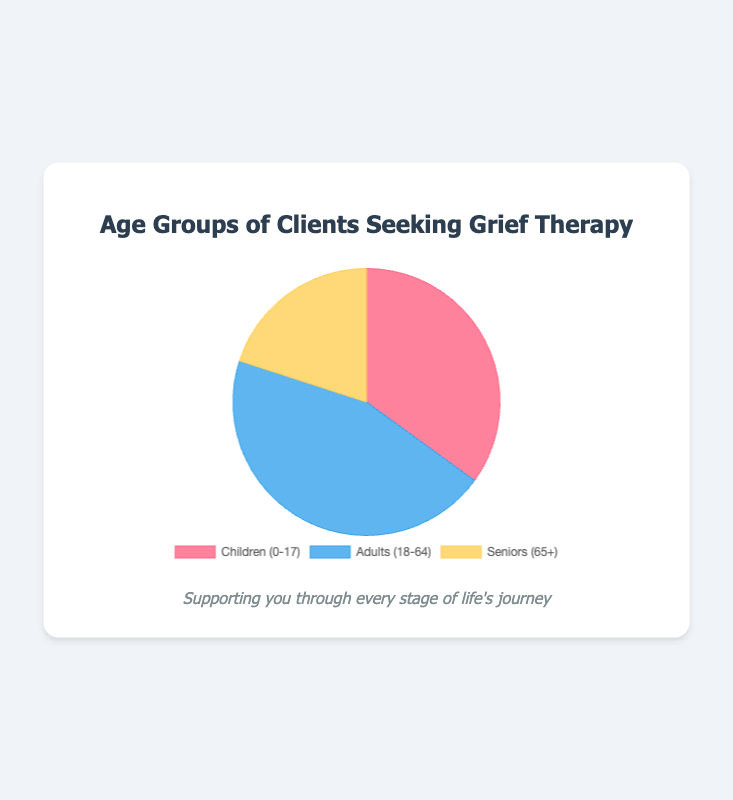Which age group has the highest percentage of clients seeking grief therapy? By observing the pie chart, the 'Adults (18-64)' segment is visually the largest portion.
Answer: Adults (18-64) How many more clients are there in the 'Adults (18-64)' group compared to the 'Seniors (65+)' group? The 'Adults (18-64)' group has 45 clients, and the 'Seniors (65+)' group has 20 clients. The difference is 45 - 20 = 25.
Answer: 25 Which color represents the 'Children (0-17)' group in the pie chart? The 'Children (0-17)' group is represented by the red section in the pie chart.
Answer: Red What is the total percentage of clients aged 0-17 and 65+? The 'Children (0-17)' group has 35 clients and the 'Seniors (65+)' group has 20 clients. Combined, they make up 35 + 20 = 55 clients out of 100, so the total percentage is 55%.
Answer: 55% Is the percentage of clients in the 'Children (0-17)' group greater than the 'Seniors (65+)' group? The 'Children (0-17)' group has 35 clients, and the 'Seniors (65+)' group has 20 clients. Since 35 is greater than 20, the percentage is greater for the 'Children (0-17)' group.
Answer: Yes What is the combined percentage of adults and seniors seeking grief therapy? The 'Adults (18-64)' group has 45 clients and the 'Seniors (65+)' group has 20 clients, making a combined total of 45 + 20 = 65 out of 100 clients, corresponding to 65%.
Answer: 65% What percentage of clients are in the 'Adults (18-64)' group? The 'Adults (18-64)' group has 45 clients out of a total of 100 clients. Therefore, the percentage is 45%.
Answer: 45% Which group is represented by the blue section in the pie chart? Observing the pie chart's colors, the blue section corresponds to the 'Adults (18-64)' group.
Answer: Adults (18-64) Comparing 'Children (0-17)' and 'Seniors (65+)', which group shows a higher number of clients seeking therapy and by what margin? The 'Children (0-17)' group has 35 clients, while the 'Seniors (65+)' group has 20 clients. The margin is 35 - 20 = 15 clients.
Answer: Children (0-17), 15 clients 